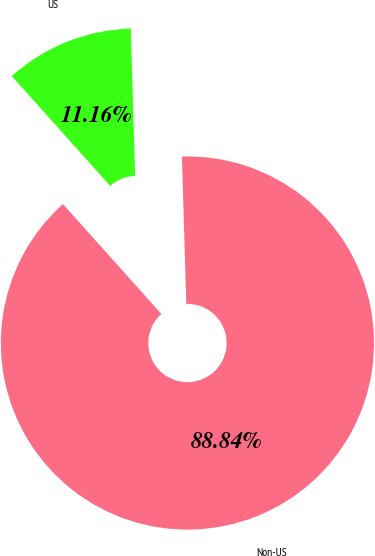Convert chart. <chart><loc_0><loc_0><loc_500><loc_500><pie_chart><fcel>US<fcel>Non-US<nl><fcel>11.16%<fcel>88.84%<nl></chart> 